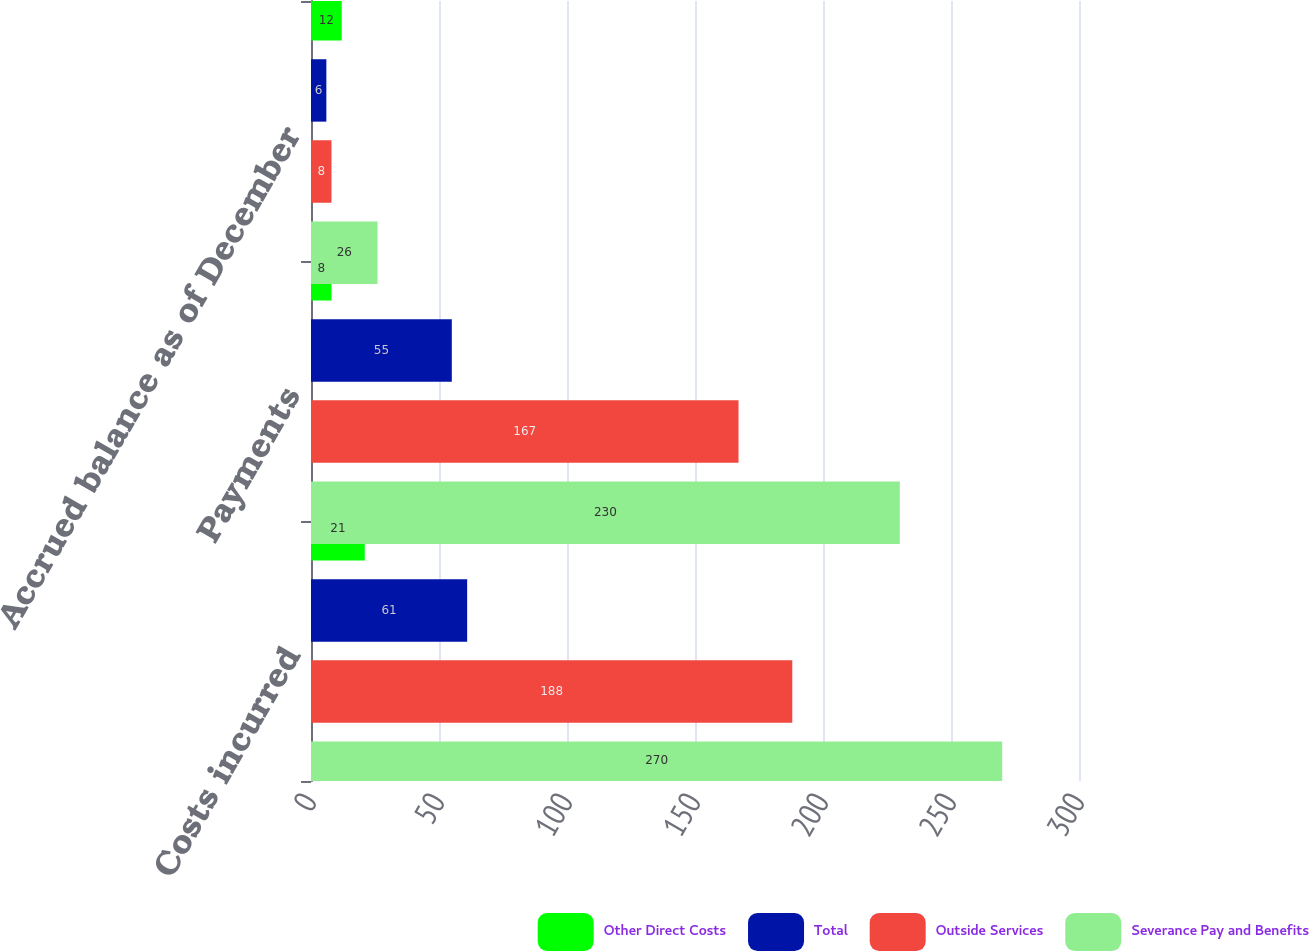Convert chart. <chart><loc_0><loc_0><loc_500><loc_500><stacked_bar_chart><ecel><fcel>Costs incurred<fcel>Payments<fcel>Accrued balance as of December<nl><fcel>Other Direct Costs<fcel>21<fcel>8<fcel>12<nl><fcel>Total<fcel>61<fcel>55<fcel>6<nl><fcel>Outside Services<fcel>188<fcel>167<fcel>8<nl><fcel>Severance Pay and Benefits<fcel>270<fcel>230<fcel>26<nl></chart> 